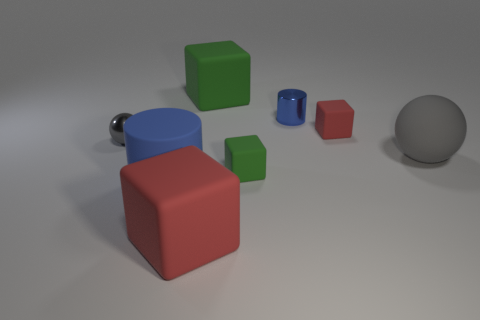Are there any other things that have the same size as the blue metallic cylinder? While it is not possible to accurately compare sizes without specific measurements, visually it seems that the smaller green cube might be similar in size to the blue metallic cylinder, although their shapes are different. 